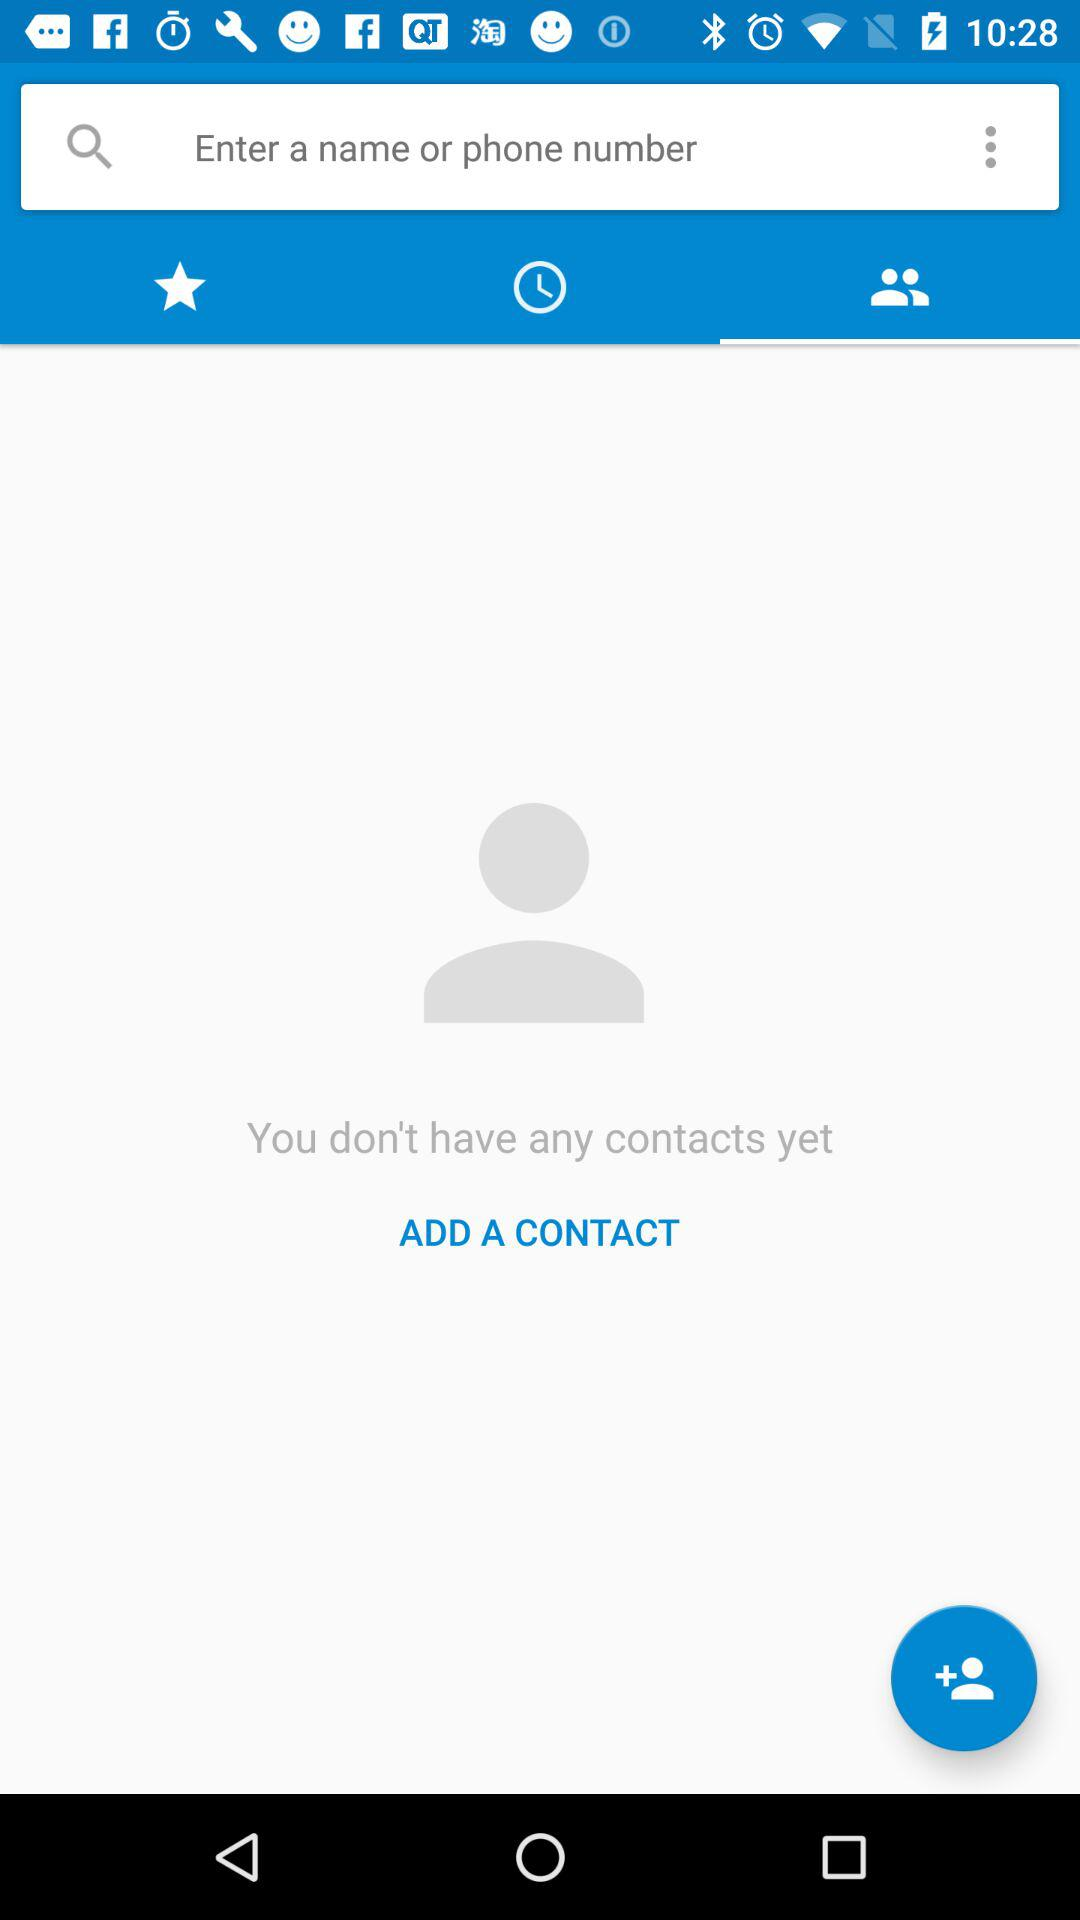Which tab is selected? The selected tab is Contacts. 